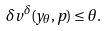<formula> <loc_0><loc_0><loc_500><loc_500>\delta v ^ { \delta } ( y _ { \theta } , p ) \leq \theta .</formula> 